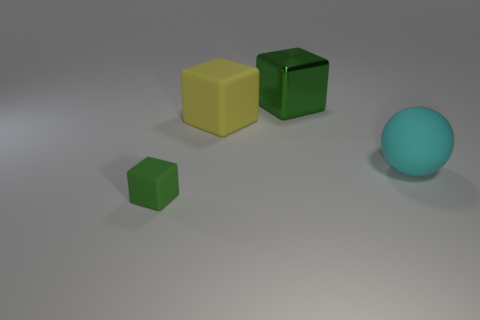Subtract all rubber blocks. How many blocks are left? 1 Add 3 tiny green metallic cubes. How many objects exist? 7 Subtract all yellow cubes. How many cubes are left? 2 Subtract 0 blue cylinders. How many objects are left? 4 Subtract all spheres. How many objects are left? 3 Subtract 1 balls. How many balls are left? 0 Subtract all gray blocks. Subtract all red spheres. How many blocks are left? 3 Subtract all brown cubes. How many yellow spheres are left? 0 Subtract all green objects. Subtract all green shiny blocks. How many objects are left? 1 Add 3 green blocks. How many green blocks are left? 5 